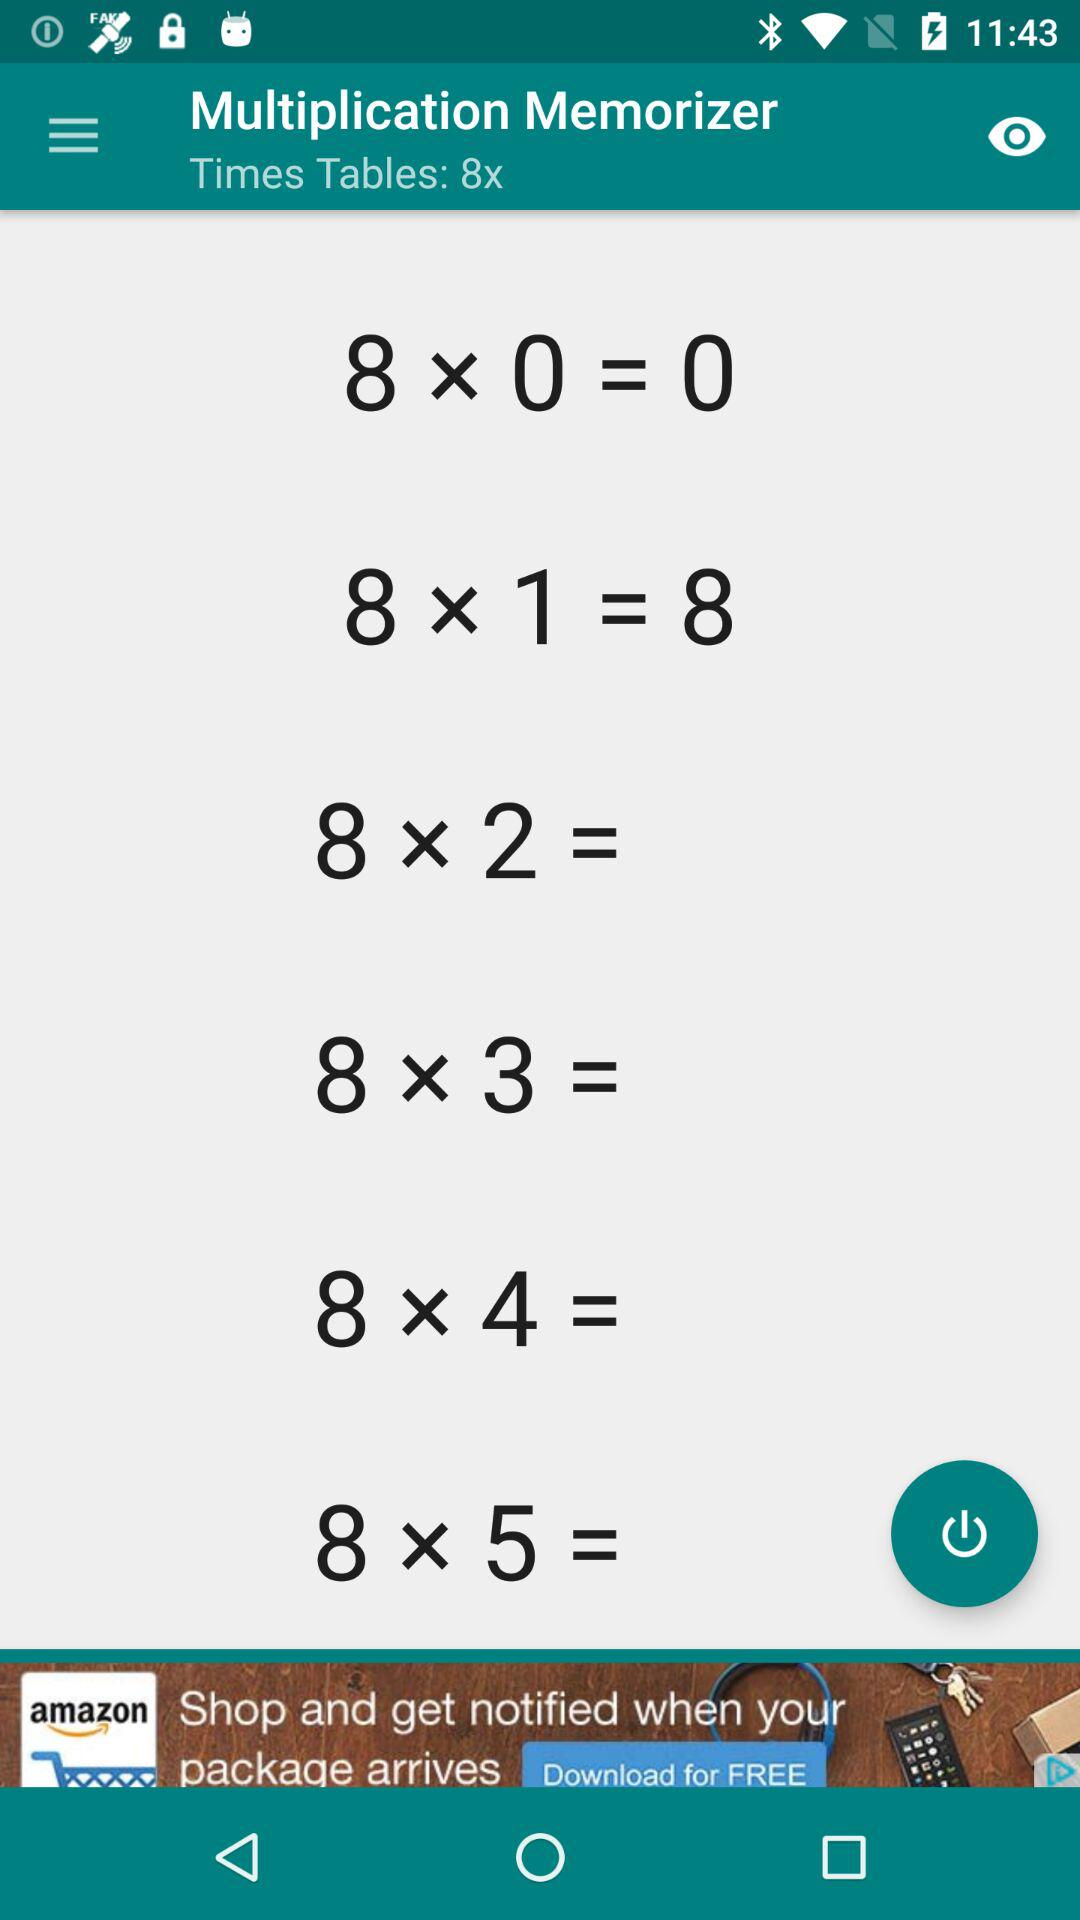What is the name of the application? The name of the application is "Multiplication Memorizer". 